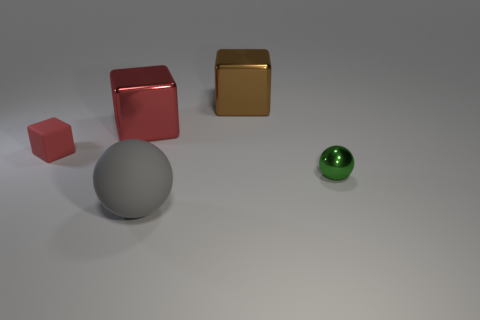There is another cube that is the same color as the small rubber cube; what material is it?
Ensure brevity in your answer.  Metal. What number of other things are the same color as the large rubber object?
Make the answer very short. 0. Is the shape of the red thing behind the rubber cube the same as the matte thing that is in front of the green sphere?
Your answer should be compact. No. How many things are either small things that are to the right of the tiny block or spheres that are to the right of the gray thing?
Offer a very short reply. 1. What number of other things are the same material as the large gray ball?
Provide a succinct answer. 1. Does the large cube in front of the brown metal block have the same material as the tiny green ball?
Your response must be concise. Yes. Is the number of red cubes in front of the big red metallic block greater than the number of large gray rubber balls behind the large brown metal block?
Provide a short and direct response. Yes. What number of things are either large things in front of the green metallic thing or gray objects?
Give a very brief answer. 1. The thing that is made of the same material as the small cube is what shape?
Give a very brief answer. Sphere. Is there anything else that has the same shape as the tiny green metallic thing?
Ensure brevity in your answer.  Yes. 